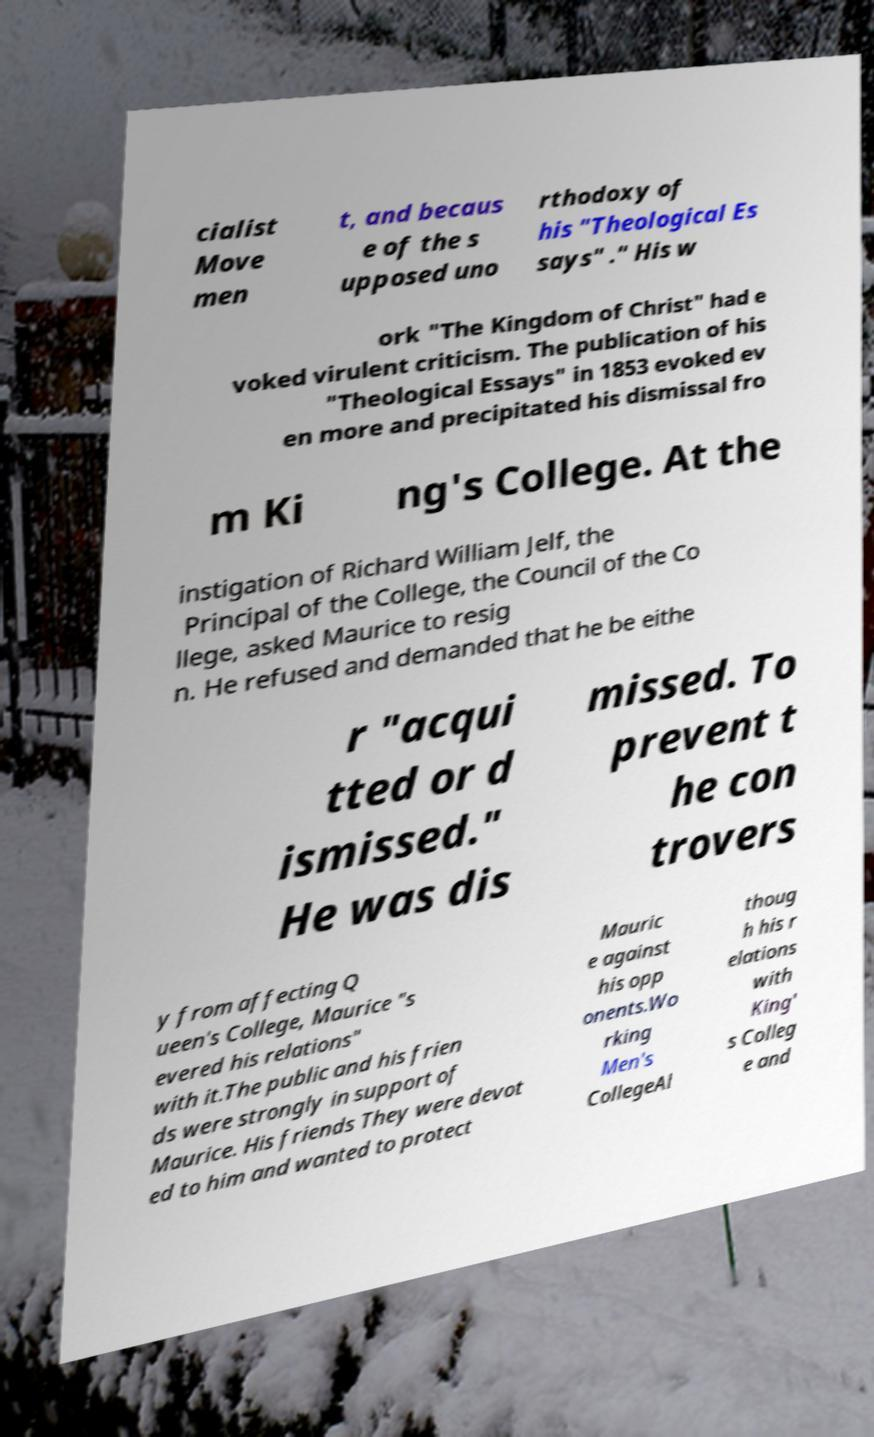I need the written content from this picture converted into text. Can you do that? cialist Move men t, and becaus e of the s upposed uno rthodoxy of his "Theological Es says" ." His w ork "The Kingdom of Christ" had e voked virulent criticism. The publication of his "Theological Essays" in 1853 evoked ev en more and precipitated his dismissal fro m Ki ng's College. At the instigation of Richard William Jelf, the Principal of the College, the Council of the Co llege, asked Maurice to resig n. He refused and demanded that he be eithe r "acqui tted or d ismissed." He was dis missed. To prevent t he con trovers y from affecting Q ueen's College, Maurice "s evered his relations" with it.The public and his frien ds were strongly in support of Maurice. His friends They were devot ed to him and wanted to protect Mauric e against his opp onents.Wo rking Men's CollegeAl thoug h his r elations with King' s Colleg e and 